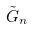<formula> <loc_0><loc_0><loc_500><loc_500>\tilde { G } _ { n }</formula> 